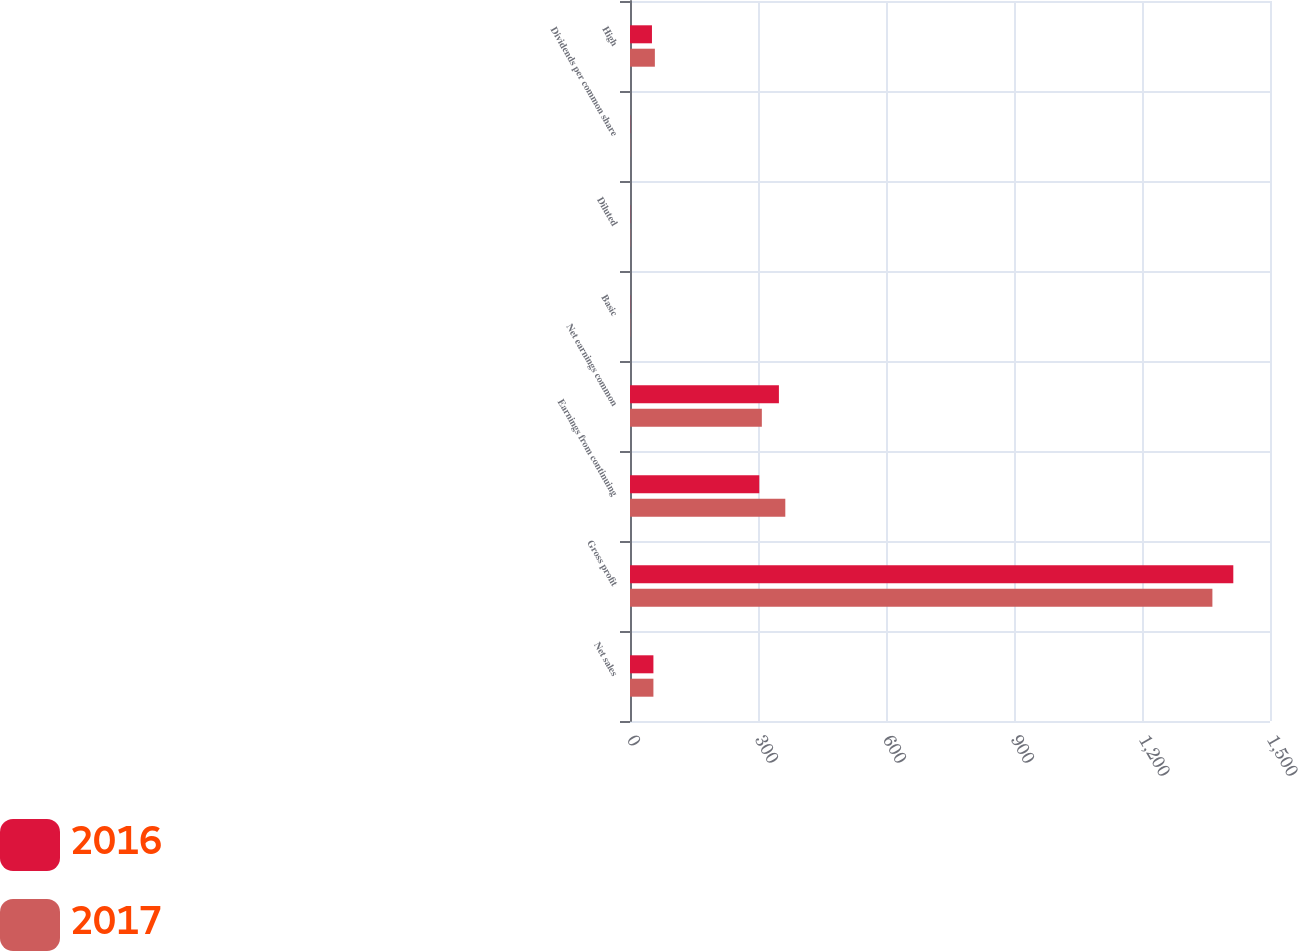Convert chart. <chart><loc_0><loc_0><loc_500><loc_500><stacked_bar_chart><ecel><fcel>Net sales<fcel>Gross profit<fcel>Earnings from continuing<fcel>Net earnings common<fcel>Basic<fcel>Diluted<fcel>Dividends per common share<fcel>High<nl><fcel>2016<fcel>54.875<fcel>1414<fcel>303<fcel>349<fcel>0.47<fcel>0.46<fcel>0.47<fcel>51.47<nl><fcel>2017<fcel>54.875<fcel>1365<fcel>364<fcel>309<fcel>0.56<fcel>0.56<fcel>0.48<fcel>58.28<nl></chart> 